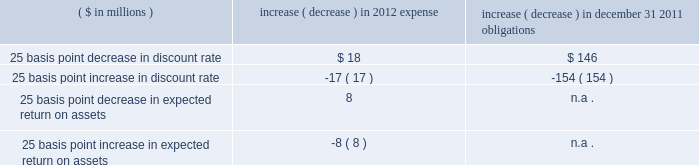Discount rate 2014the assumed discount rate is used to determine the current retirement related benefit plan expense and obligations , and represents the interest rate that is used to determine the present value of future cash flows currently expected to be required to effectively settle a plan 2019s benefit obligations .
The discount rate assumption is determined for each plan by constructing a portfolio of high quality bonds with cash flows that match the estimated outflows for future benefit payments to determine a single equivalent discount rate .
Benefit payments are not only contingent on the terms of a plan , but also on the underlying participant demographics , including current age , and assumed mortality .
We use only bonds that are denominated in u.s .
Dollars , rated aa or better by two of three nationally recognized statistical rating agencies , have a minimum outstanding issue of $ 50 million as of the measurement date , and are not callable , convertible , or index linked .
Since bond yields are generally unavailable beyond 30 years , we assume those rates will remain constant beyond that point .
Taking into consideration the factors noted above , our weighted average discount rate for pensions was 5.23% ( 5.23 % ) and 5.84% ( 5.84 % ) , as of december 31 , 2011 and 2010 , respectively .
Our weighted average discount rate for other postretirement benefits was 4.94% ( 4.94 % ) and 5.58% ( 5.58 % ) as of december 31 , 2011 and 2010 , respectively .
Expected long-term rate of return 2014the expected long-term rate of return on assets is used to calculate net periodic expense , and is based on such factors as historical returns , targeted asset allocations , investment policy , duration , expected future long-term performance of individual asset classes , inflation trends , portfolio volatility , and risk management strategies .
While studies are helpful in understanding current trends and performance , the assumption is based more on longer term and prospective views .
In order to reflect expected lower future market returns , we have reduced the expected long-term rate of return assumption from 8.50% ( 8.50 % ) , used to record 2011 expense , to 8.00% ( 8.00 % ) for 2012 .
The decrease in the expected return on assets assumption is primarily related to lower bond yields and updated return assumptions for equities .
Unless plan assets and benefit obligations are subject to remeasurement during the year , the expected return on pension assets is based on the fair value of plan assets at the beginning of the year .
An increase or decrease of 25 basis points in the discount rate and the expected long-term rate of return assumptions would have had the following approximate impacts on pensions : ( $ in millions ) increase ( decrease ) in 2012 expense increase ( decrease ) in december 31 , 2011 obligations .
Differences arising from actual experience or changes in assumptions might materially affect retirement related benefit plan obligations and the funded status .
Actuarial gains and losses arising from differences from actual experience or changes in assumptions are deferred in accumulated other comprehensive income .
This unrecognized amount is amortized to the extent it exceeds 10% ( 10 % ) of the greater of the plan 2019s benefit obligation or plan assets .
The amortization period for actuarial gains and losses is the estimated average remaining service life of the plan participants , which is approximately 10 years .
Cas expense 2014in addition to providing the methodology for calculating retirement related benefit plan costs , cas also prescribes the method for assigning those costs to specific periods .
While the ultimate liability for such costs under fas and cas is similar , the pattern of cost recognition is different .
The key drivers of cas pension expense include the funded status and the method used to calculate cas reimbursement for each of our plans as well as our expected long-term rate of return on assets assumption .
Unlike fas , cas requires the discount rate to be consistent with the expected long-term rate of return on assets assumption , which changes infrequently given its long-term nature .
As a result , changes in bond or other interest rates generally do not impact cas .
In addition , unlike under fas , we can only allocate pension costs for a plan under cas until such plan is fully funded as determined under erisa requirements .
Other fas and cas considerations 2014we update our estimates of future fas and cas costs at least annually based on factors such as calendar year actual plan asset returns , final census data from the end of the prior year , and other actual and projected experience .
A key driver of the difference between fas and cas expense ( and consequently , the fas/cas adjustment ) is the pattern of earnings and expense recognition for gains and losses that arise when our asset and liability experiences differ from our assumptions under each set of requirements .
Under fas , our net gains and losses exceeding the 10% ( 10 % ) corridor are amortized .
What was the ratio of the 25 basis point decrease in discount rate to the expected return on assets expense in 2012? 
Rationale: the rate of the 25 basis point decrease in discount rate in 2012 to the 25 basis point decrease in expected return on assets was 2.25 to 1
Computations: (18 / 8)
Answer: 2.25. Discount rate 2014the assumed discount rate is used to determine the current retirement related benefit plan expense and obligations , and represents the interest rate that is used to determine the present value of future cash flows currently expected to be required to effectively settle a plan 2019s benefit obligations .
The discount rate assumption is determined for each plan by constructing a portfolio of high quality bonds with cash flows that match the estimated outflows for future benefit payments to determine a single equivalent discount rate .
Benefit payments are not only contingent on the terms of a plan , but also on the underlying participant demographics , including current age , and assumed mortality .
We use only bonds that are denominated in u.s .
Dollars , rated aa or better by two of three nationally recognized statistical rating agencies , have a minimum outstanding issue of $ 50 million as of the measurement date , and are not callable , convertible , or index linked .
Since bond yields are generally unavailable beyond 30 years , we assume those rates will remain constant beyond that point .
Taking into consideration the factors noted above , our weighted average discount rate for pensions was 5.23% ( 5.23 % ) and 5.84% ( 5.84 % ) , as of december 31 , 2011 and 2010 , respectively .
Our weighted average discount rate for other postretirement benefits was 4.94% ( 4.94 % ) and 5.58% ( 5.58 % ) as of december 31 , 2011 and 2010 , respectively .
Expected long-term rate of return 2014the expected long-term rate of return on assets is used to calculate net periodic expense , and is based on such factors as historical returns , targeted asset allocations , investment policy , duration , expected future long-term performance of individual asset classes , inflation trends , portfolio volatility , and risk management strategies .
While studies are helpful in understanding current trends and performance , the assumption is based more on longer term and prospective views .
In order to reflect expected lower future market returns , we have reduced the expected long-term rate of return assumption from 8.50% ( 8.50 % ) , used to record 2011 expense , to 8.00% ( 8.00 % ) for 2012 .
The decrease in the expected return on assets assumption is primarily related to lower bond yields and updated return assumptions for equities .
Unless plan assets and benefit obligations are subject to remeasurement during the year , the expected return on pension assets is based on the fair value of plan assets at the beginning of the year .
An increase or decrease of 25 basis points in the discount rate and the expected long-term rate of return assumptions would have had the following approximate impacts on pensions : ( $ in millions ) increase ( decrease ) in 2012 expense increase ( decrease ) in december 31 , 2011 obligations .
Differences arising from actual experience or changes in assumptions might materially affect retirement related benefit plan obligations and the funded status .
Actuarial gains and losses arising from differences from actual experience or changes in assumptions are deferred in accumulated other comprehensive income .
This unrecognized amount is amortized to the extent it exceeds 10% ( 10 % ) of the greater of the plan 2019s benefit obligation or plan assets .
The amortization period for actuarial gains and losses is the estimated average remaining service life of the plan participants , which is approximately 10 years .
Cas expense 2014in addition to providing the methodology for calculating retirement related benefit plan costs , cas also prescribes the method for assigning those costs to specific periods .
While the ultimate liability for such costs under fas and cas is similar , the pattern of cost recognition is different .
The key drivers of cas pension expense include the funded status and the method used to calculate cas reimbursement for each of our plans as well as our expected long-term rate of return on assets assumption .
Unlike fas , cas requires the discount rate to be consistent with the expected long-term rate of return on assets assumption , which changes infrequently given its long-term nature .
As a result , changes in bond or other interest rates generally do not impact cas .
In addition , unlike under fas , we can only allocate pension costs for a plan under cas until such plan is fully funded as determined under erisa requirements .
Other fas and cas considerations 2014we update our estimates of future fas and cas costs at least annually based on factors such as calendar year actual plan asset returns , final census data from the end of the prior year , and other actual and projected experience .
A key driver of the difference between fas and cas expense ( and consequently , the fas/cas adjustment ) is the pattern of earnings and expense recognition for gains and losses that arise when our asset and liability experiences differ from our assumptions under each set of requirements .
Under fas , our net gains and losses exceeding the 10% ( 10 % ) corridor are amortized .
What was the net change in the 25 basis point decrease and increase in discount rate in 2012 in millions? 
Rationale: the net change in 2012 was the sum of the increase and decrease in the 25 basis point discount rate
Computations: (18 + -17)
Answer: 1.0. 